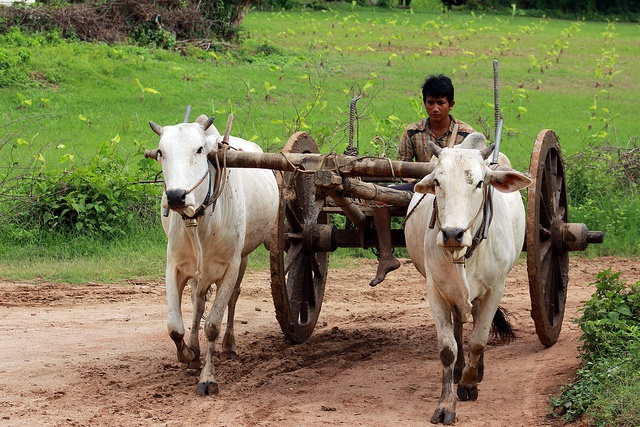Describe the objects in this image and their specific colors. I can see cow in white, lightgray, darkgray, and gray tones, cow in white, lightgray, darkgray, gray, and tan tones, and people in white, black, maroon, and gray tones in this image. 